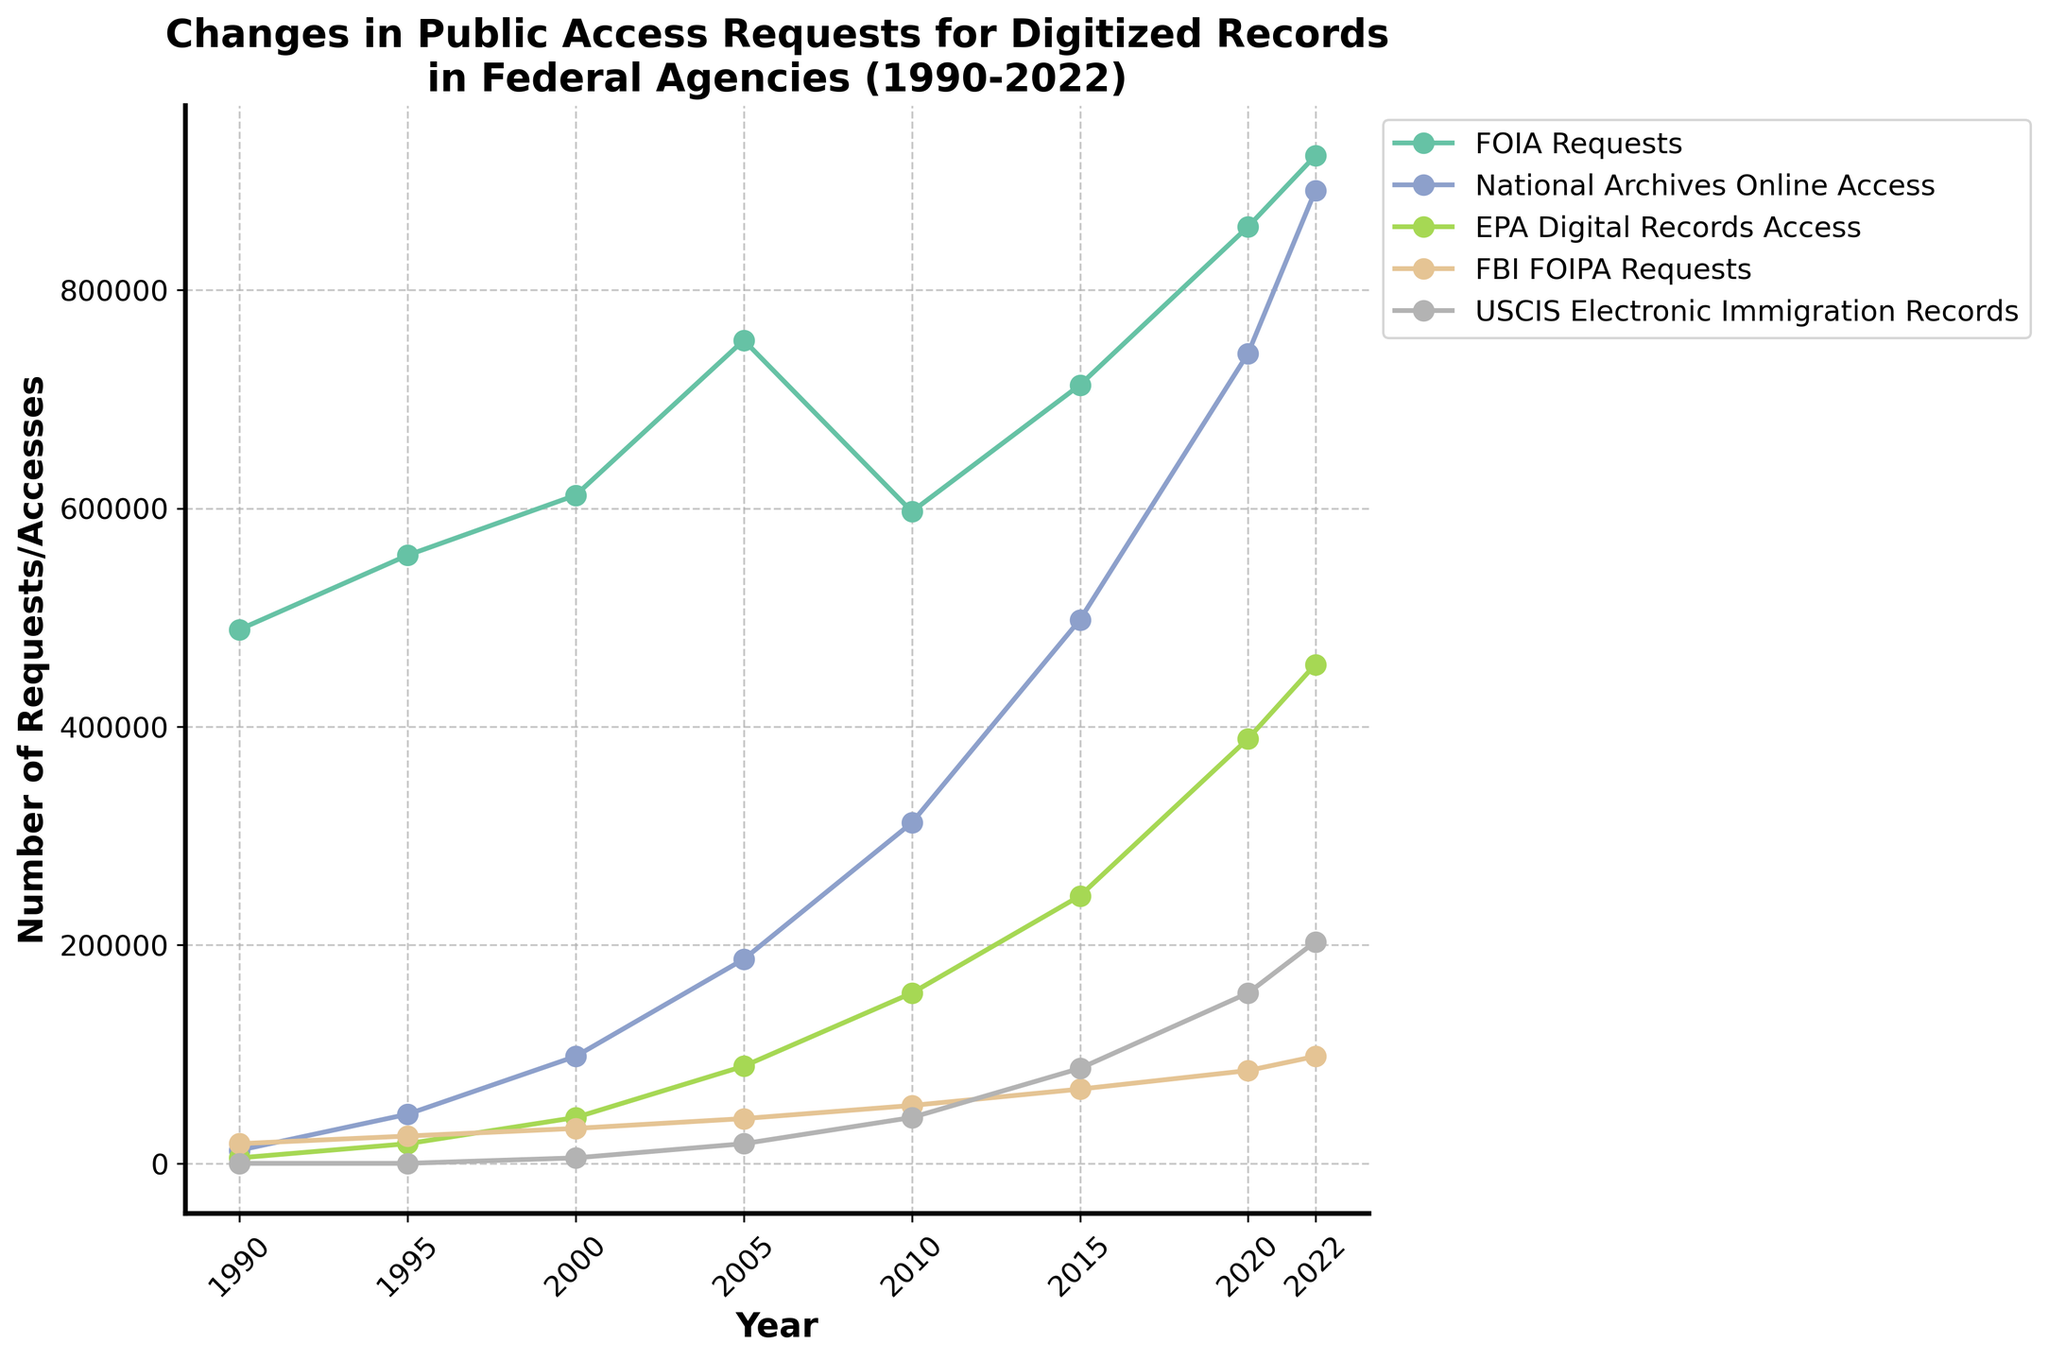What is the highest number of FOIA Requests in any given year? To find the highest number of FOIA Requests, we need to look at the data points for FOIA Requests across all years and identify the maximum value. The FOIA Requests reach their peak in the year 2022 with 923,000 requests.
Answer: 923,000 Between which years did National Archives Online Access see the largest increase? To determine the largest increase, calculate the difference in National Archives Online Access requests between consecutive years, then identify the maximum increase. The largest increase is from 2015 to 2020, where the requests increased from 498,000 to 742,000, a difference of 244,000.
Answer: 2015-2020 Which federal agency had the lowest number of requests in 1990? Compare the request numbers for all federal agencies in 1990. The USCIS Electronic Immigration Records had zero requests in 1990, which is the lowest.
Answer: USCIS Electronic Immigration Records What is the total number of public access requests for EPA Digital Records Access from 1990 to 2022? To find the total number of requests, add up all the data points for EPA Digital Records Access across the given years. The total is 5,000 + 18,000 + 42,000 + 89,000 + 156,000 + 245,000 + 389,000 + 457,000 = 1,401,000.
Answer: 1,401,000 How does the increase in FOIA Requests from 1990 to 2022 compare to that of the FBI FOIPA Requests? Calculate the difference for both FOIA Requests and FBI FOIPA Requests between 1990 and 2022, then compare them. FOIA Requests increased by 923,000 - 489,000 = 434,000, while FBI FOIPA Requests increased by 98,000 - 18,000 = 80,000. FOIA Requests saw a larger increase.
Answer: FOIA Requests had a larger increase Which agency's access requests showed the most continuous upward trend from 1990 to 2022? Observing the plot, identify the agency whose curve consistently rises without any significant drops. National Archives Online Access shows a continuous upward trend from 1990 to 2022.
Answer: National Archives Online Access In which year did USCIS Electronic Immigration Records exceed 100,000 access requests for the first time? Examine the data points for USCIS Electronic Immigration Records and identify the first year where the number exceeds 100,000. USCIS Electronic Immigration Records exceeded 100,000 for the first time in 2020.
Answer: 2020 What is the average number of FOIA Requests in the first decade (1990-2000)? To find the average, sum the FOIA Requests for the years 1990, 1995, and 2000, and then divide by the number of years (i.e., 3). The sum is 489,000 + 557,000 + 612,000 = 1,658,000, so the average is 1,658,000 / 3 ≈ 552,667.
Answer: 552,667 Of the five federal agencies, which one had the second highest number of requests in 2022? To determine the second highest number of requests in 2022, list the requests for all five agencies that year and identify the second largest value. The list is FOIA Requests: 923,000, National Archives Online Access: 891,000, EPA Digital Records Access: 457,000, FBI FOIPA Requests: 98,000, USCIS Electronic Immigration Records: 203,000. The second highest is National Archives Online Access with 891,000 requests.
Answer: National Archives Online Access 